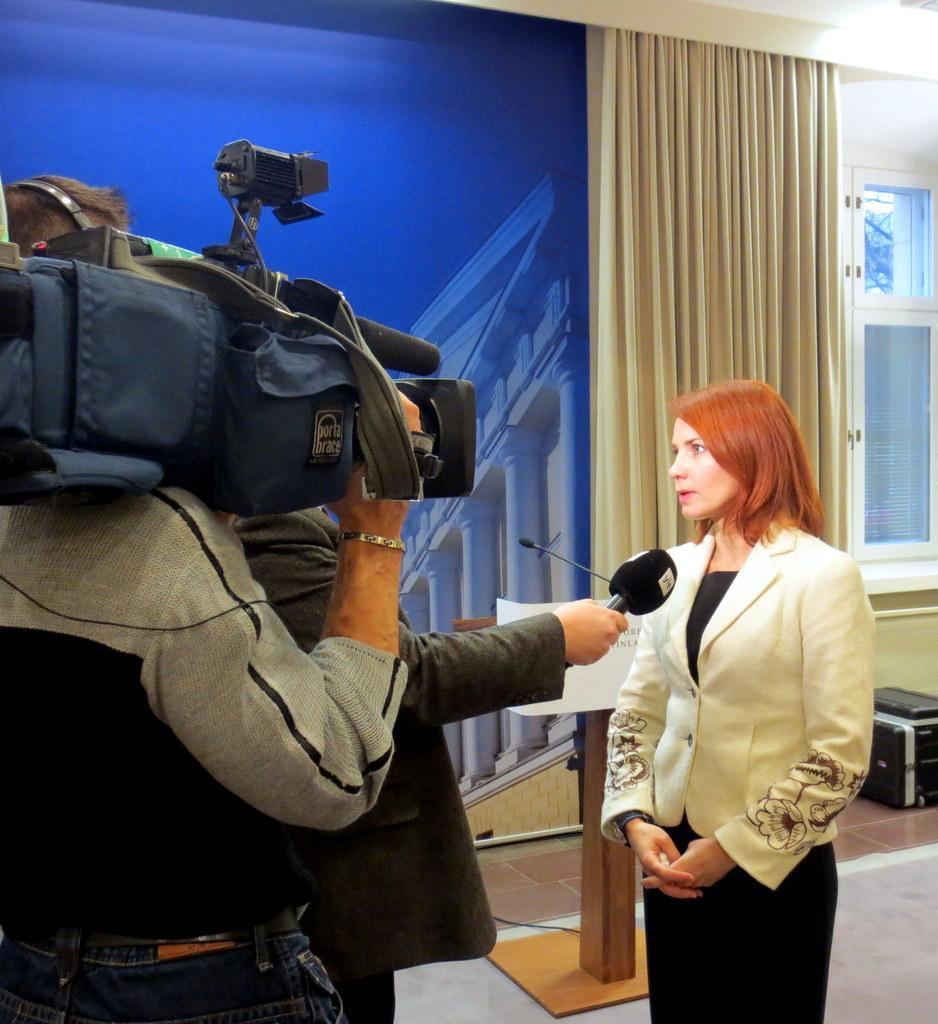Describe this image in one or two sentences. In the image there is a woman being interviewed by a person and behind the person there is a man standing by holding a camera, in the background there is a table, poster, curtain and window. 